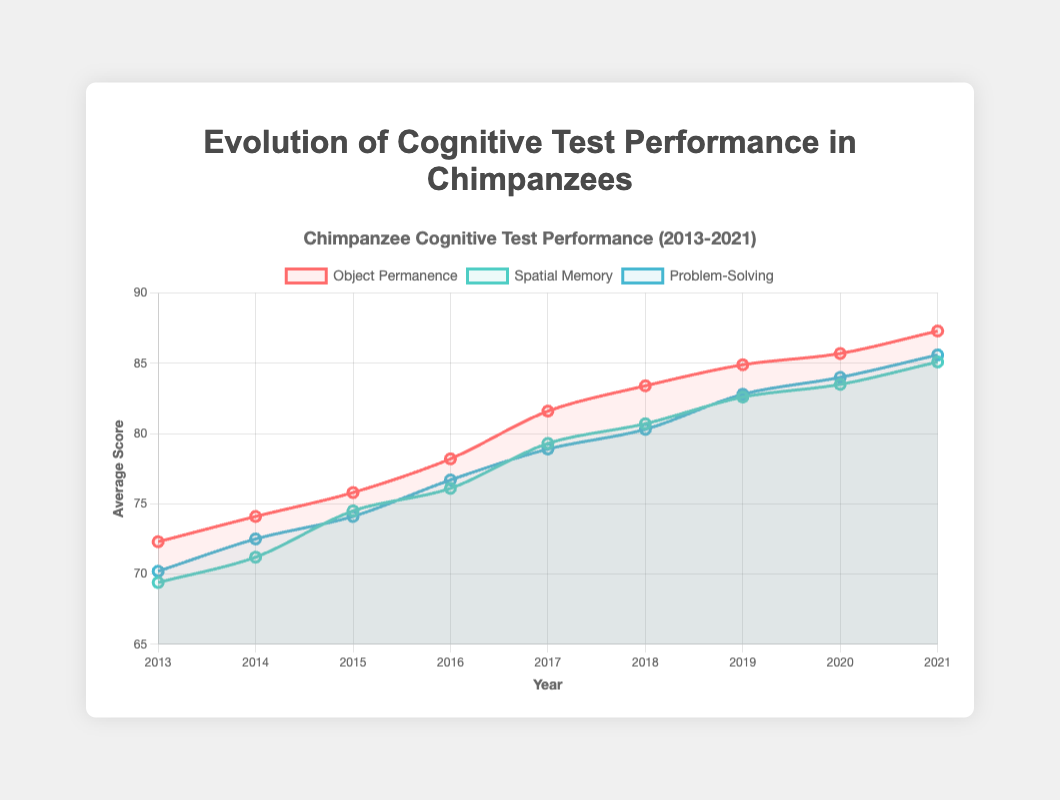What was the average score for Object Permanence in 2015? Refer to the data points for Object Permanence in the year 2015 in the line plot. The corresponding data point shows an average score of 75.8.
Answer: 75.8 What is the difference between the highest and lowest scores for Spatial Memory over the years? For Spatial Memory, the lowest score in 2013 is 69.4, and the highest score in 2021 is 85.1. The difference is calculated as 85.1 - 69.4.
Answer: 15.7 Which cognitive test shows the steepest increase in average scores from 2013 to 2021? Compare the slopes of the lines for the three cognitive tests. Problem-Solving has the steepest increase, starting at 70.2 in 2013 and ending at 85.6 in 2021, with an increase of 15.4 points.
Answer: Problem-Solving How did the Object Permanence scores change between 2017 and 2018? The Object Permanence scores increased from 81.6 in 2017 to 83.4 in 2018. This results in an increase of 83.4 - 81.6.
Answer: Increased by 1.8 In which year did Problem-Solving surpass an average score of 80 for the first time? Look at the Problem-Solving scores across the years. It first surpasses 80 in 2018 with a score of 80.3.
Answer: 2018 Comparing 2013, which cognitive test showed the greatest improvement by 2021 in terms of average score? Calculate the improvements for each test from 2013 to 2021. Object Permanence improved from 72.3 to 87.3 (15 points), Spatial Memory improved from 69.4 to 85.1 (15.7 points), and Problem-Solving improved from 70.2 to 85.6 (15.4 points). Therefore, Spatial Memory had the greatest improvement.
Answer: Spatial Memory What is the combined average score for all three cognitive tests in the year 2016? Sum the average scores for all cognitive tests in 2016: Object Permanence (78.2), Spatial Memory (76.1), Problem-Solving (76.7). Then find the average: (78.2 + 76.1 + 76.7) / 3.
Answer: 77 How many years did it take for each cognitive test to reach an average score greater than 80? Count the number of years from 2013 to when each test first exceeded an average score of 80. Object Permanence reached it in 2017, Spatial Memory in 2018, and Problem-Solving in 2018. So, it takes 5 years for Object Permanence, 6 for Spatial Memory, and 5 for Problem-Solving.
Answer: Object Permanence: 5 years, Spatial Memory: 6 years, Problem-Solving: 5 years Which cognitive test had the smallest variation in scores over the years? Look at the line plots and determine which test shows the least fluctuation. Spatial Memory appears to have the smallest variation with a more consistent upward trend compared to others.
Answer: Spatial Memory 